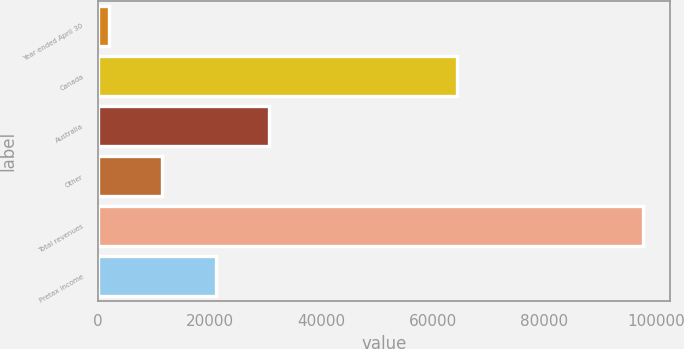Convert chart to OTSL. <chart><loc_0><loc_0><loc_500><loc_500><bar_chart><fcel>Year ended April 30<fcel>Canada<fcel>Australia<fcel>Other<fcel>Total revenues<fcel>Pretax income<nl><fcel>2004<fcel>64238<fcel>30670.8<fcel>11559.6<fcel>97560<fcel>21115.2<nl></chart> 